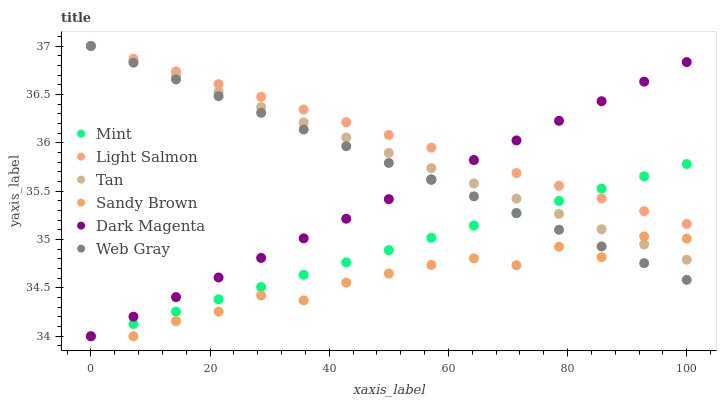Does Sandy Brown have the minimum area under the curve?
Answer yes or no. Yes. Does Light Salmon have the maximum area under the curve?
Answer yes or no. Yes. Does Web Gray have the minimum area under the curve?
Answer yes or no. No. Does Web Gray have the maximum area under the curve?
Answer yes or no. No. Is Light Salmon the smoothest?
Answer yes or no. Yes. Is Sandy Brown the roughest?
Answer yes or no. Yes. Is Web Gray the smoothest?
Answer yes or no. No. Is Web Gray the roughest?
Answer yes or no. No. Does Dark Magenta have the lowest value?
Answer yes or no. Yes. Does Web Gray have the lowest value?
Answer yes or no. No. Does Tan have the highest value?
Answer yes or no. Yes. Does Dark Magenta have the highest value?
Answer yes or no. No. Is Sandy Brown less than Light Salmon?
Answer yes or no. Yes. Is Light Salmon greater than Sandy Brown?
Answer yes or no. Yes. Does Web Gray intersect Tan?
Answer yes or no. Yes. Is Web Gray less than Tan?
Answer yes or no. No. Is Web Gray greater than Tan?
Answer yes or no. No. Does Sandy Brown intersect Light Salmon?
Answer yes or no. No. 